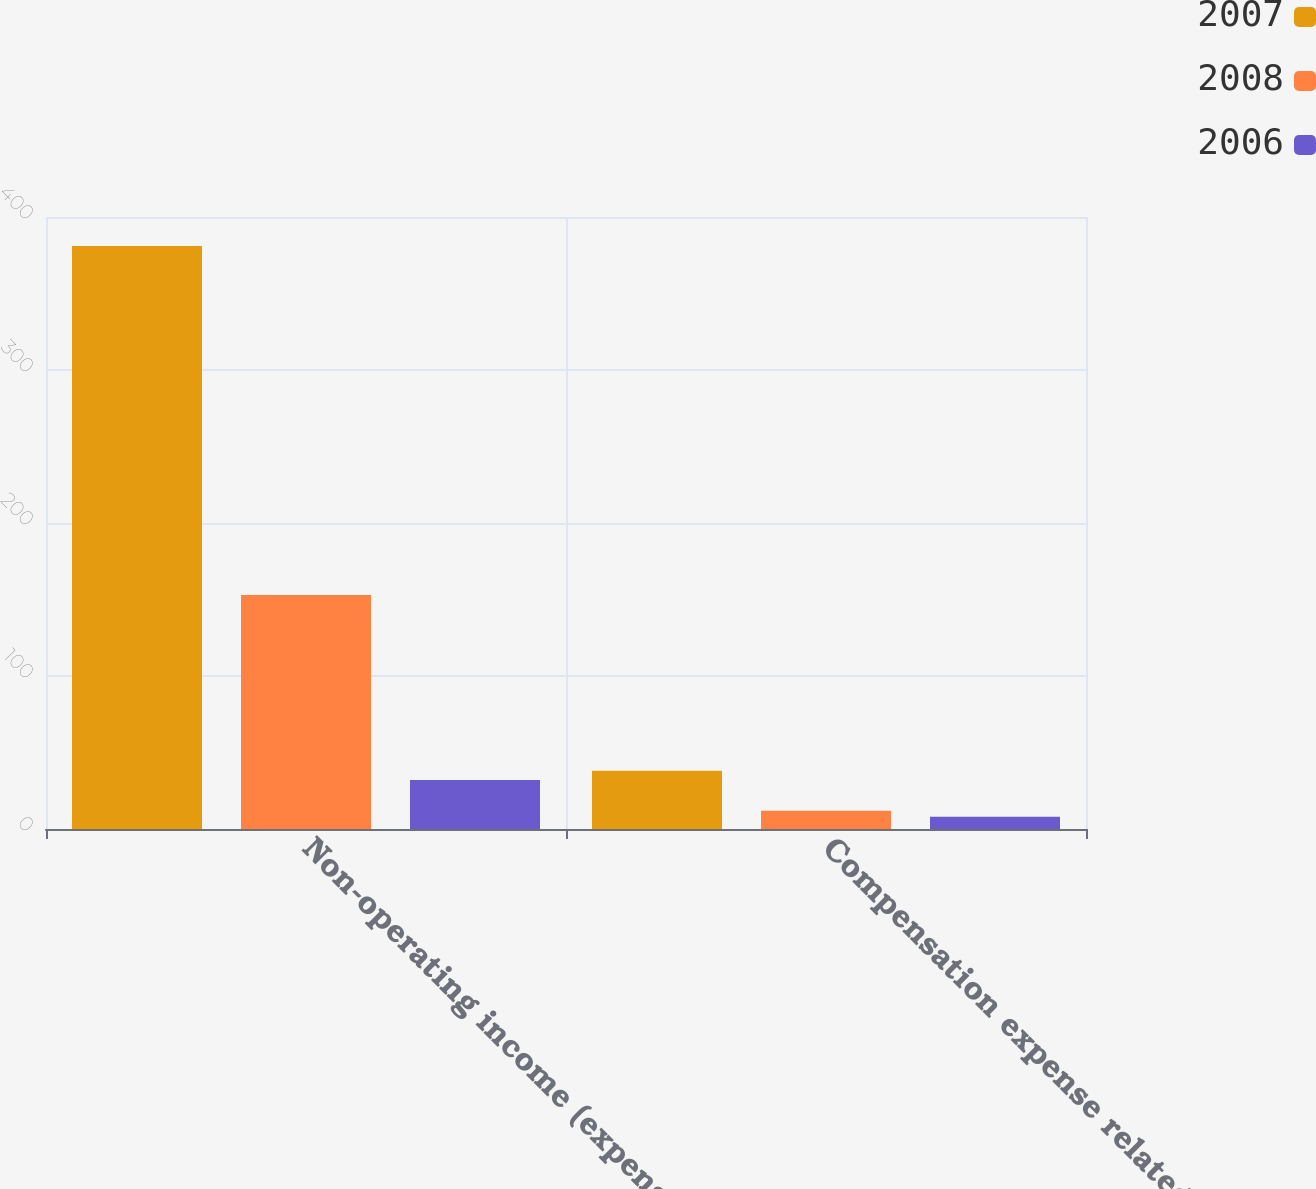Convert chart to OTSL. <chart><loc_0><loc_0><loc_500><loc_500><stacked_bar_chart><ecel><fcel>Non-operating income (expense)<fcel>Compensation expense related<nl><fcel>2007<fcel>381<fcel>38<nl><fcel>2008<fcel>153<fcel>12<nl><fcel>2006<fcel>32<fcel>8<nl></chart> 